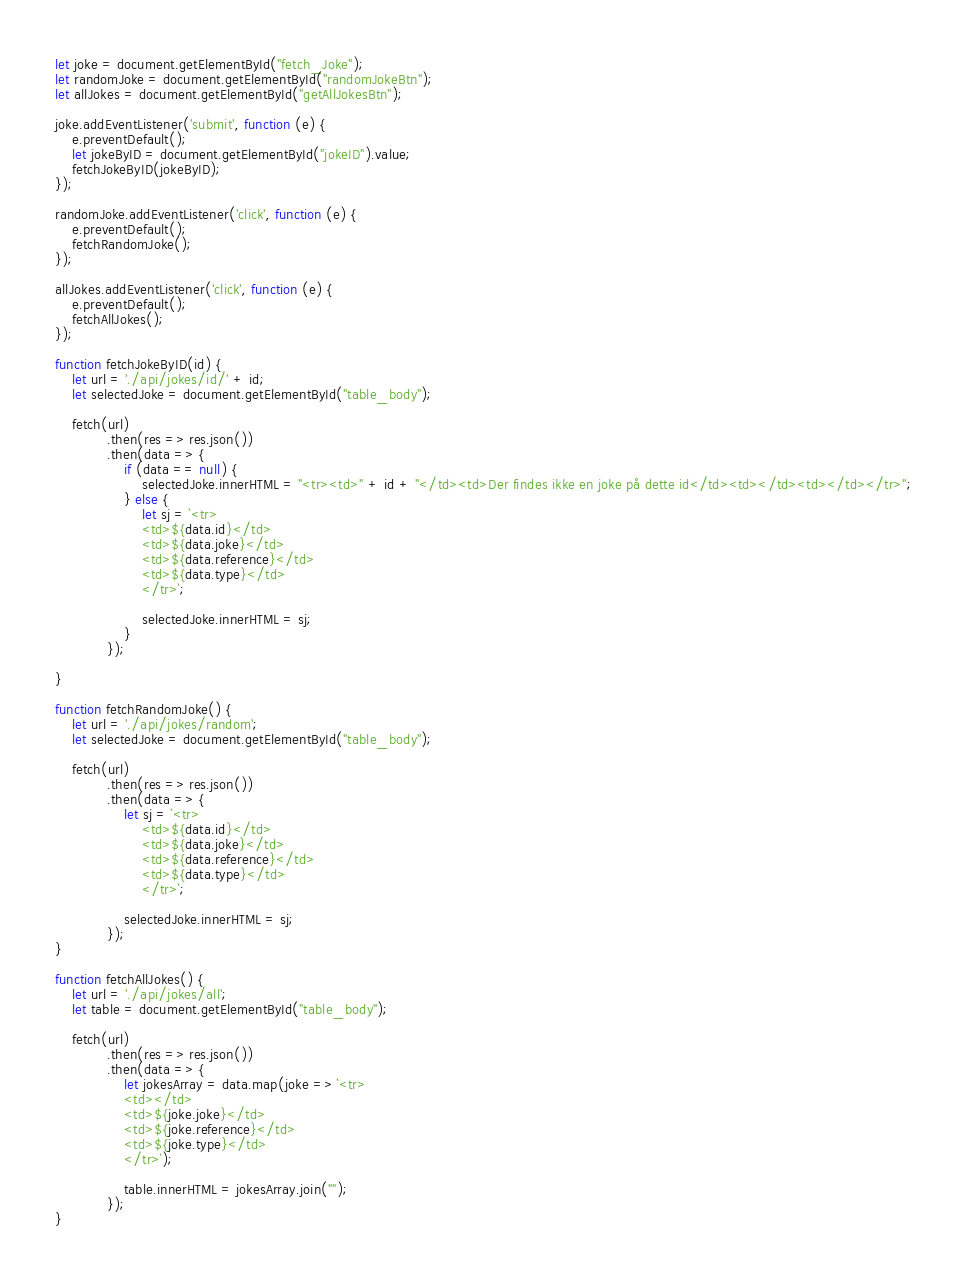Convert code to text. <code><loc_0><loc_0><loc_500><loc_500><_JavaScript_>let joke = document.getElementById("fetch_Joke");
let randomJoke = document.getElementById("randomJokeBtn");
let allJokes = document.getElementById("getAllJokesBtn");

joke.addEventListener('submit', function (e) {
    e.preventDefault();
    let jokeByID = document.getElementById("jokeID").value;
    fetchJokeByID(jokeByID);
});

randomJoke.addEventListener('click', function (e) {
    e.preventDefault();
    fetchRandomJoke();
});

allJokes.addEventListener('click', function (e) {
    e.preventDefault();
    fetchAllJokes();
});

function fetchJokeByID(id) {
    let url = './api/jokes/id/' + id;
    let selectedJoke = document.getElementById("table_body");

    fetch(url)
            .then(res => res.json())
            .then(data => {
                if (data == null) {
                    selectedJoke.innerHTML = "<tr><td>" + id + "</td><td>Der findes ikke en joke på dette id</td><td></td><td></td></tr>";
                } else {
                    let sj = `<tr>
                    <td>${data.id}</td>
                    <td>${data.joke}</td>
                    <td>${data.reference}</td>
                    <td>${data.type}</td>
                    </tr>`;

                    selectedJoke.innerHTML = sj;
                }
            });

}

function fetchRandomJoke() {
    let url = './api/jokes/random';
    let selectedJoke = document.getElementById("table_body");

    fetch(url)
            .then(res => res.json())
            .then(data => {
                let sj = `<tr>
                    <td>${data.id}</td>
                    <td>${data.joke}</td>
                    <td>${data.reference}</td>
                    <td>${data.type}</td>
                    </tr>`;

                selectedJoke.innerHTML = sj;
            });
}

function fetchAllJokes() {
    let url = './api/jokes/all';
    let table = document.getElementById("table_body");

    fetch(url)
            .then(res => res.json())
            .then(data => {
                let jokesArray = data.map(joke => `<tr>
                <td></td>
                <td>${joke.joke}</td>
                <td>${joke.reference}</td>
                <td>${joke.type}</td>
                </tr>`);

                table.innerHTML = jokesArray.join("");
            });
}</code> 